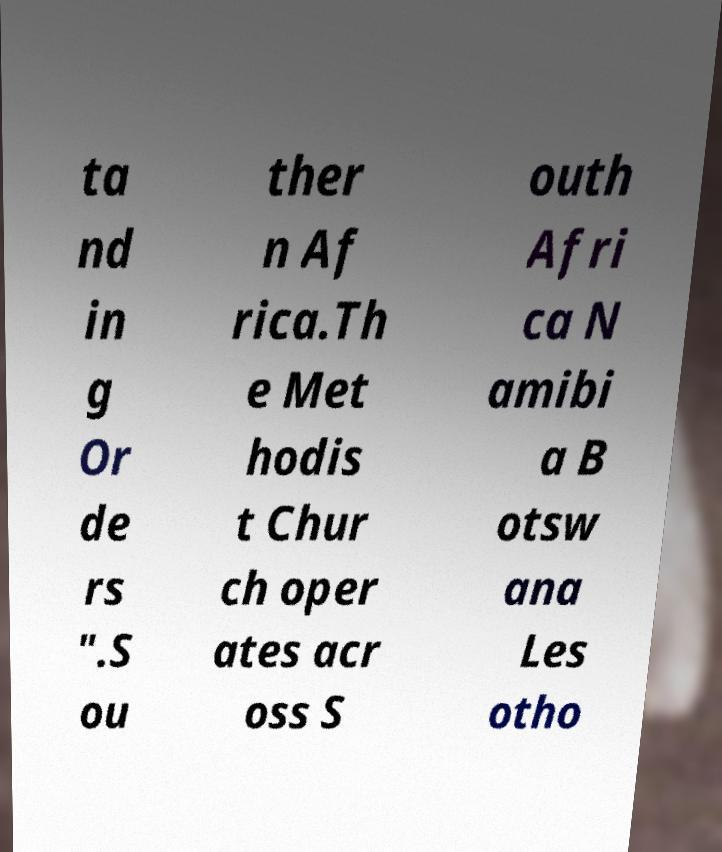Could you extract and type out the text from this image? ta nd in g Or de rs ".S ou ther n Af rica.Th e Met hodis t Chur ch oper ates acr oss S outh Afri ca N amibi a B otsw ana Les otho 